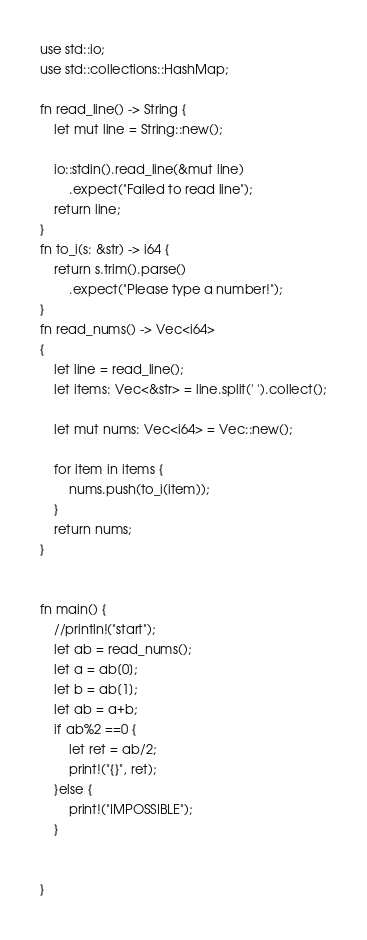<code> <loc_0><loc_0><loc_500><loc_500><_Rust_>use std::io;
use std::collections::HashMap;

fn read_line() -> String {
    let mut line = String::new();

    io::stdin().read_line(&mut line)
        .expect("Failed to read line");
    return line;
}
fn to_i(s: &str) -> i64 {
    return s.trim().parse()
        .expect("Please type a number!");
}
fn read_nums() -> Vec<i64>
{
    let line = read_line();
    let items: Vec<&str> = line.split(' ').collect();

    let mut nums: Vec<i64> = Vec::new();

    for item in items {
        nums.push(to_i(item));
    }
    return nums;
}


fn main() {
    //println!("start");
    let ab = read_nums();
    let a = ab[0];
    let b = ab[1];
    let ab = a+b;
    if ab%2 ==0 {
        let ret = ab/2;
        print!("{}", ret);
    }else {
        print!("IMPOSSIBLE");
    }
    
    
}   </code> 